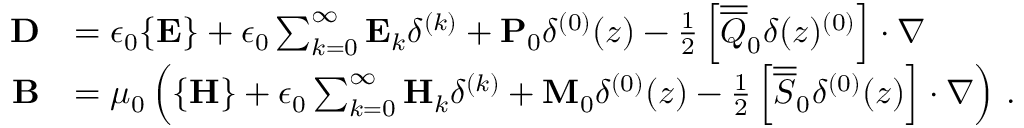<formula> <loc_0><loc_0><loc_500><loc_500>\begin{array} { r l } { D } & { = \epsilon _ { 0 } \{ E \} + \epsilon _ { 0 } \sum _ { k = 0 } ^ { \infty } E _ { k } \delta ^ { ( k ) } + P _ { 0 } \delta ^ { ( 0 ) } ( z ) - \frac { 1 } { 2 } \left [ \overline { { \overline { Q } } } _ { 0 } \delta ( z ) ^ { ( 0 ) } \right ] \cdot \nabla } \\ { B } & { = \mu _ { 0 } \left ( \{ H \} + \epsilon _ { 0 } \sum _ { k = 0 } ^ { \infty } H _ { k } \delta ^ { ( k ) } + M _ { 0 } \delta ^ { ( 0 ) } ( z ) - \frac { 1 } { 2 } \left [ \overline { { \overline { S } } } _ { 0 } \delta ^ { ( 0 ) } ( z ) \right ] \cdot \nabla \right ) \, . } \end{array}</formula> 